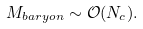Convert formula to latex. <formula><loc_0><loc_0><loc_500><loc_500>M _ { b a r y o n } \sim \mathcal { O } ( N _ { c } ) .</formula> 